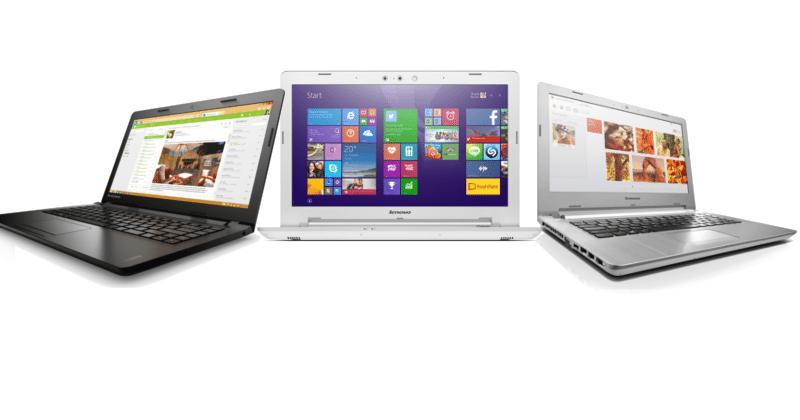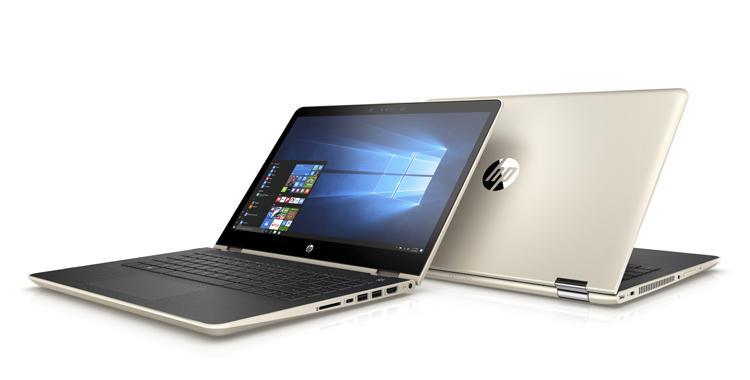The first image is the image on the left, the second image is the image on the right. For the images displayed, is the sentence "There are three laptops in at least one of the images." factually correct? Answer yes or no. Yes. The first image is the image on the left, the second image is the image on the right. Assess this claim about the two images: "Exactly three computers are shown in the left image and all three computers are open with a design shown on the screen.". Correct or not? Answer yes or no. Yes. 